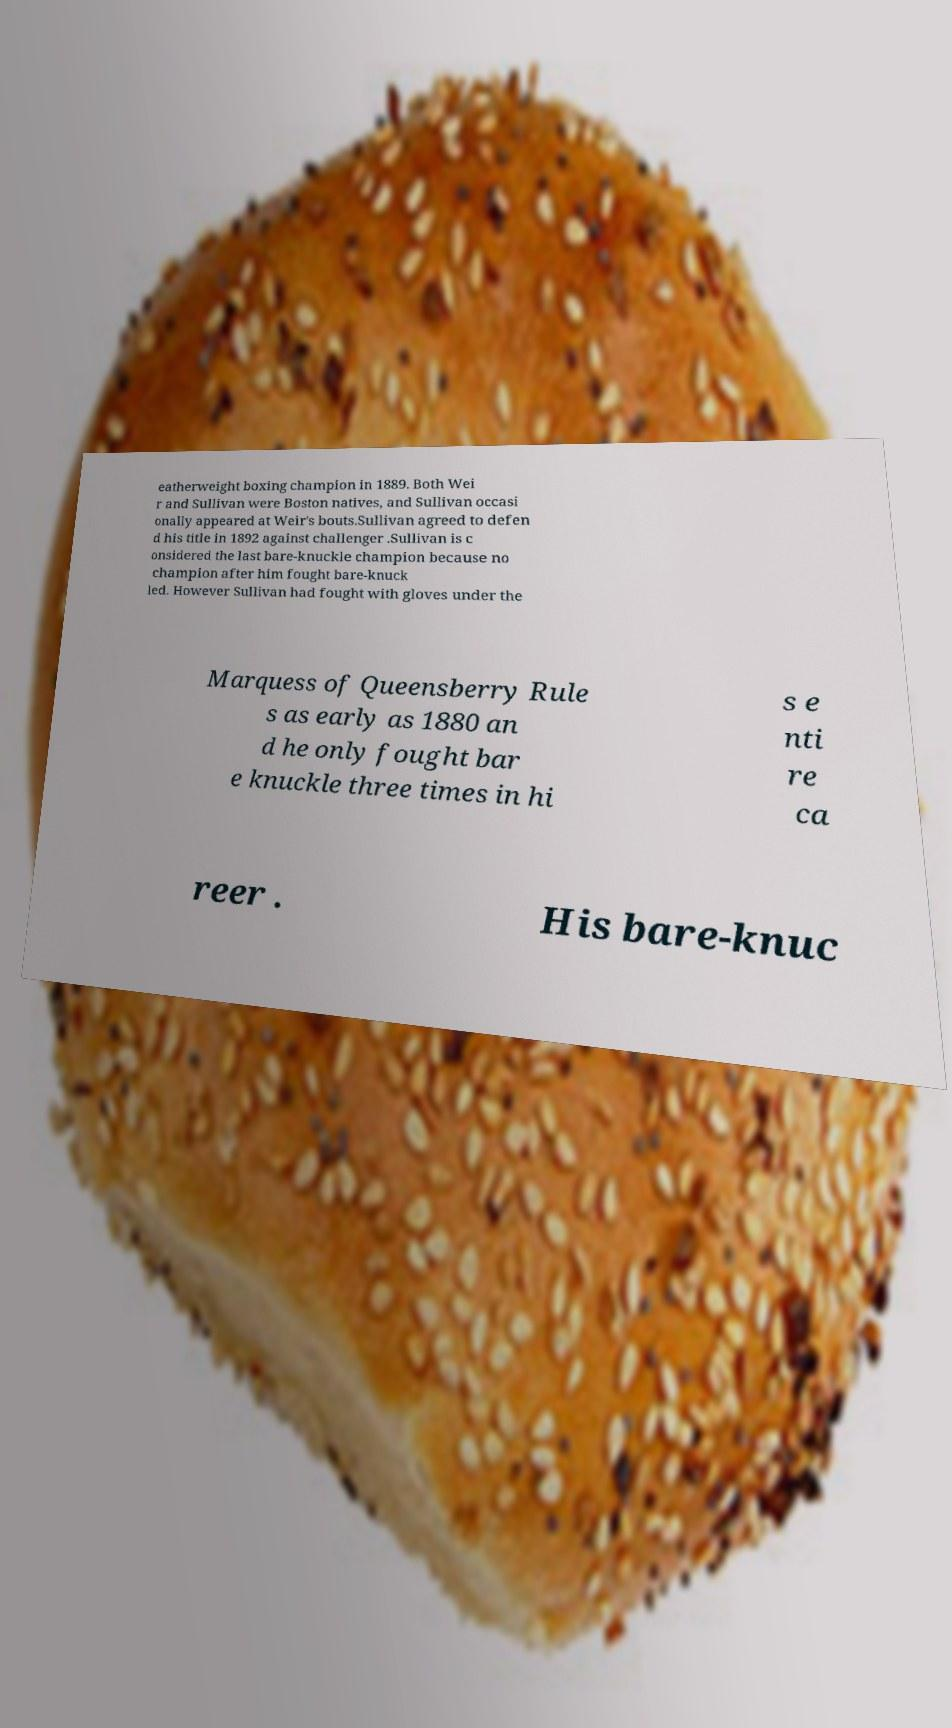For documentation purposes, I need the text within this image transcribed. Could you provide that? eatherweight boxing champion in 1889. Both Wei r and Sullivan were Boston natives, and Sullivan occasi onally appeared at Weir's bouts.Sullivan agreed to defen d his title in 1892 against challenger .Sullivan is c onsidered the last bare-knuckle champion because no champion after him fought bare-knuck led. However Sullivan had fought with gloves under the Marquess of Queensberry Rule s as early as 1880 an d he only fought bar e knuckle three times in hi s e nti re ca reer . His bare-knuc 